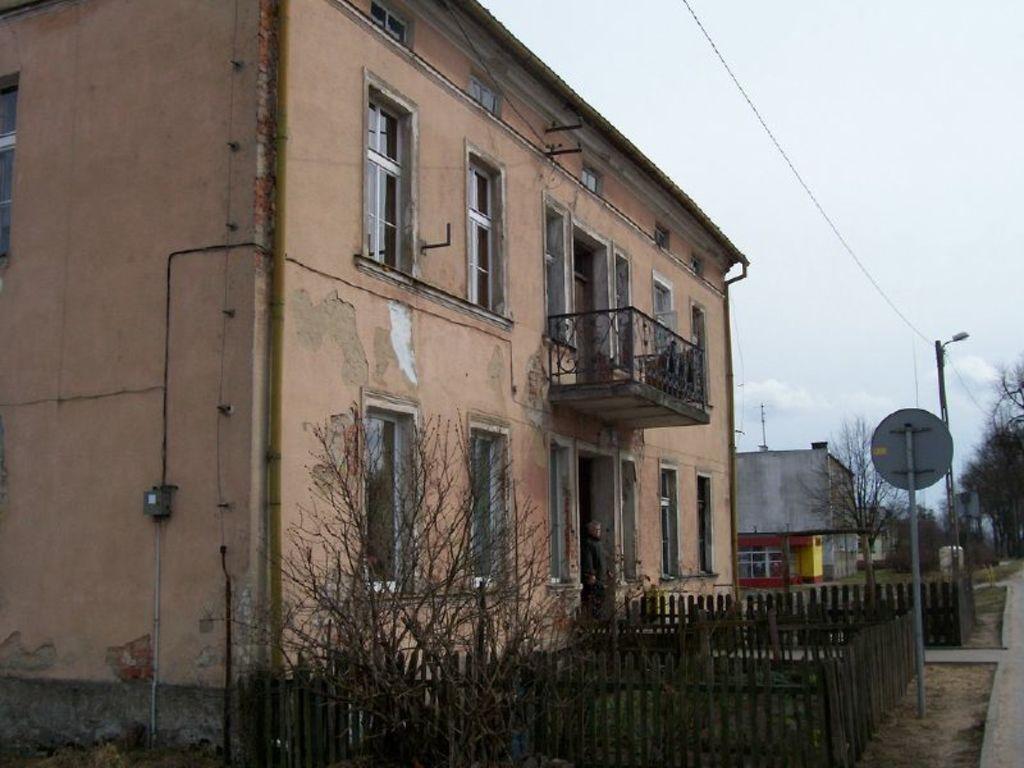Could you give a brief overview of what you see in this image? In the image there is a house and a person is standing beside the door of house and there is a wooden fencing around the house and beside the fencing there is a caution board and a street light and in the background there are lot of trees. 